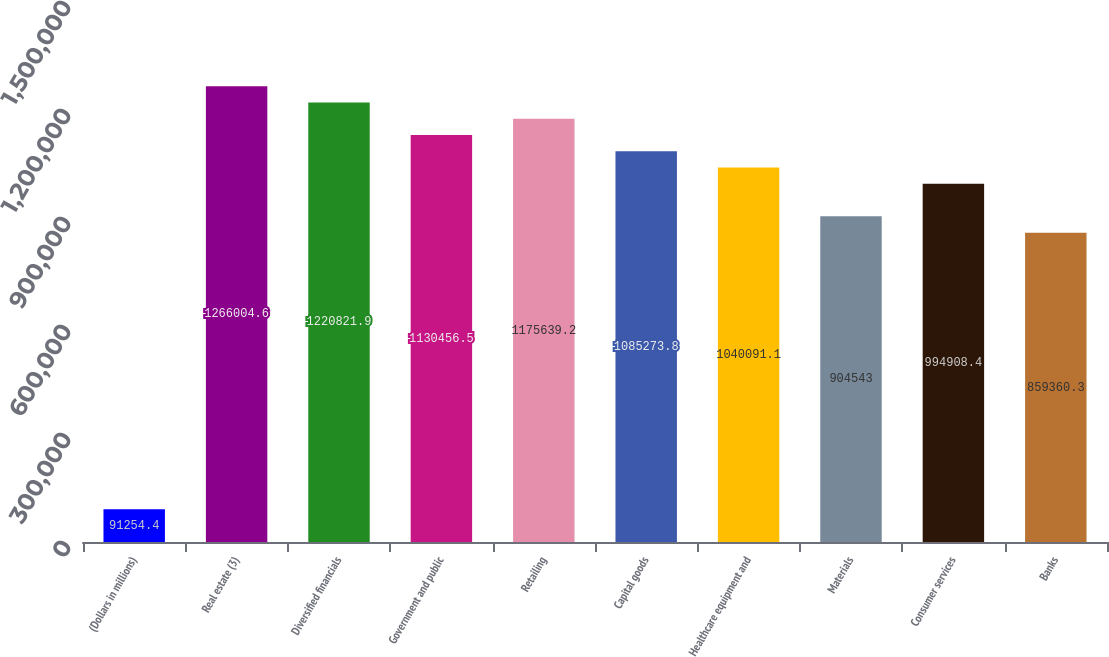Convert chart to OTSL. <chart><loc_0><loc_0><loc_500><loc_500><bar_chart><fcel>(Dollars in millions)<fcel>Real estate (3)<fcel>Diversified financials<fcel>Government and public<fcel>Retailing<fcel>Capital goods<fcel>Healthcare equipment and<fcel>Materials<fcel>Consumer services<fcel>Banks<nl><fcel>91254.4<fcel>1.266e+06<fcel>1.22082e+06<fcel>1.13046e+06<fcel>1.17564e+06<fcel>1.08527e+06<fcel>1.04009e+06<fcel>904543<fcel>994908<fcel>859360<nl></chart> 